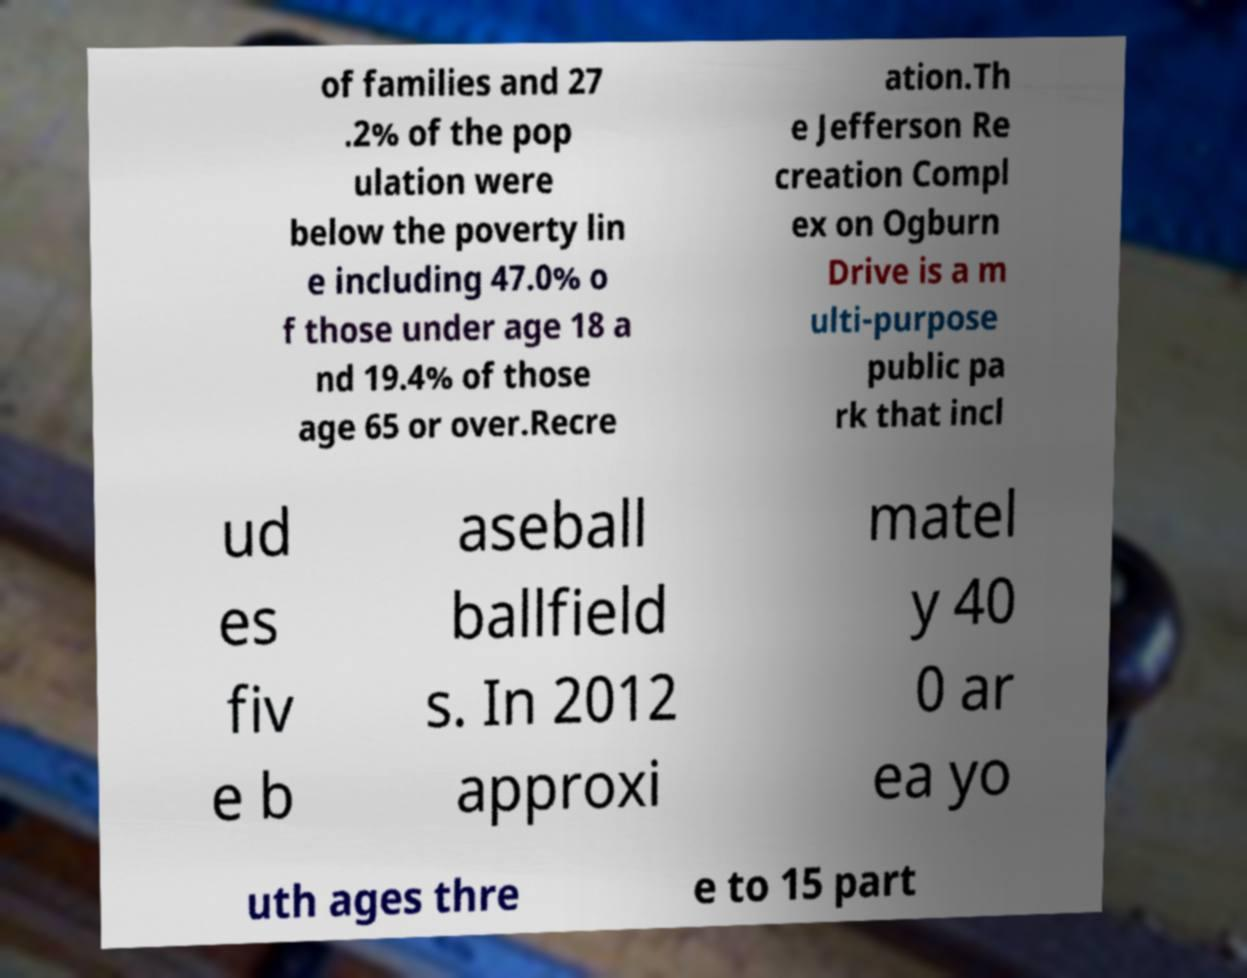Can you accurately transcribe the text from the provided image for me? of families and 27 .2% of the pop ulation were below the poverty lin e including 47.0% o f those under age 18 a nd 19.4% of those age 65 or over.Recre ation.Th e Jefferson Re creation Compl ex on Ogburn Drive is a m ulti-purpose public pa rk that incl ud es fiv e b aseball ballfield s. In 2012 approxi matel y 40 0 ar ea yo uth ages thre e to 15 part 